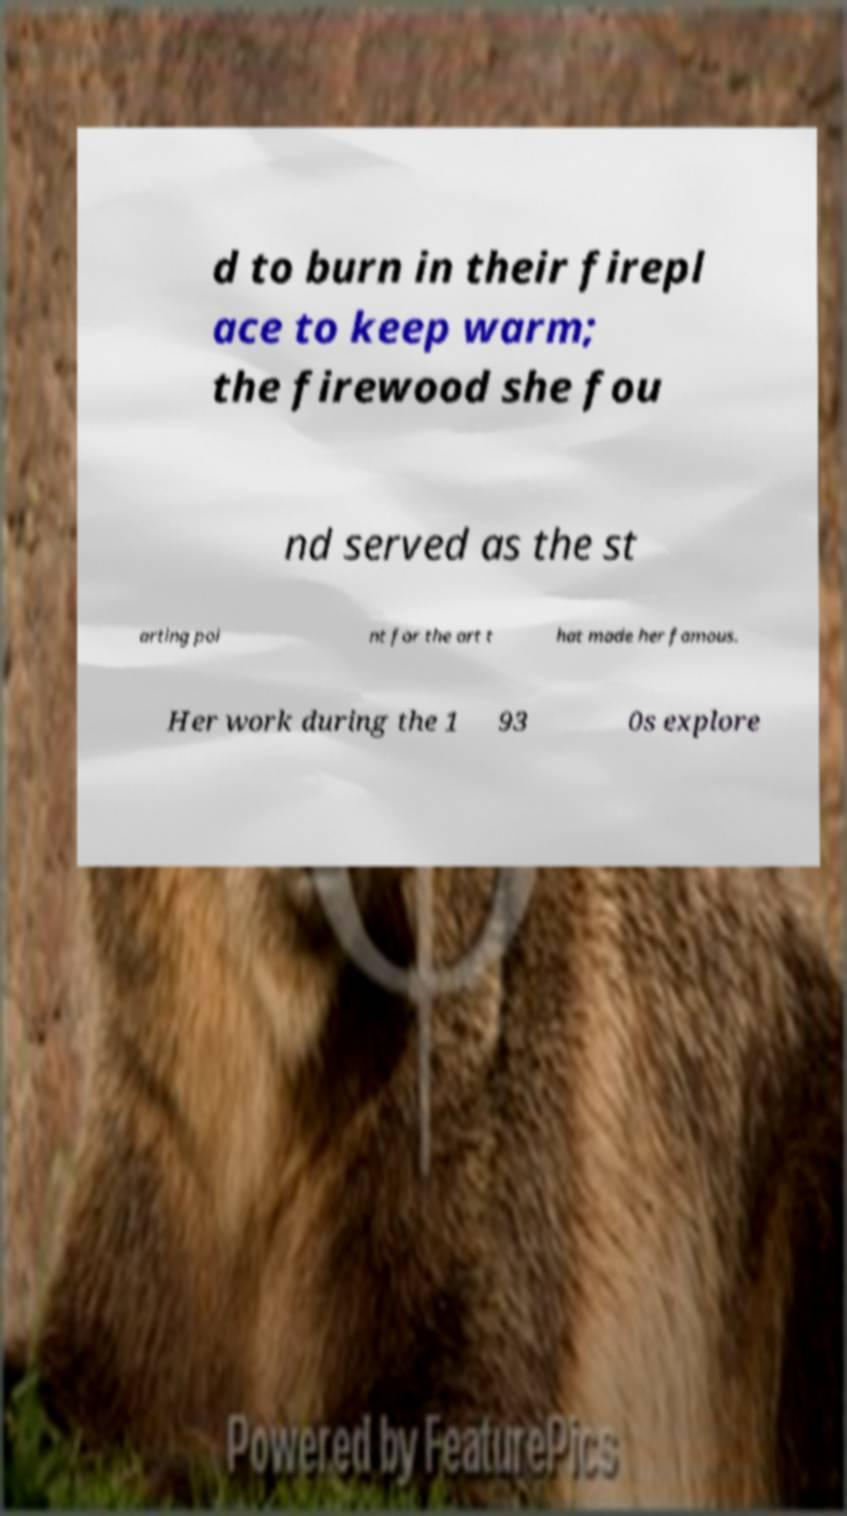Please identify and transcribe the text found in this image. d to burn in their firepl ace to keep warm; the firewood she fou nd served as the st arting poi nt for the art t hat made her famous. Her work during the 1 93 0s explore 